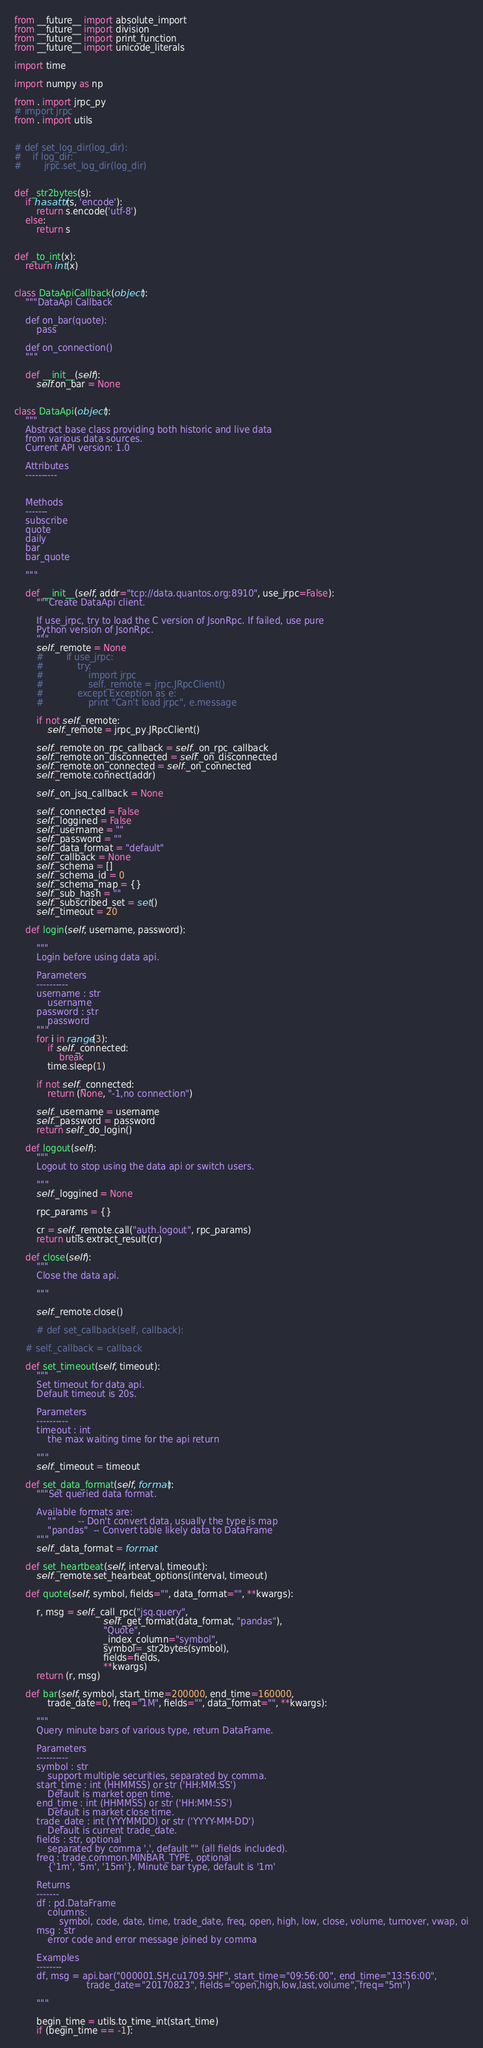<code> <loc_0><loc_0><loc_500><loc_500><_Python_>from __future__ import absolute_import
from __future__ import division
from __future__ import print_function
from __future__ import unicode_literals

import time

import numpy as np

from . import jrpc_py
# import jrpc
from . import utils


# def set_log_dir(log_dir):
#    if log_dir:
#        jrpc.set_log_dir(log_dir)


def _str2bytes(s):
    if hasattr(s, 'encode'):
        return s.encode('utf-8')
    else:
        return s


def _to_int(x):
    return int(x)


class DataApiCallback(object):
    """DataApi Callback

    def on_bar(quote):
        pass
        
    def on_connection()
    """
    
    def __init__(self):
        self.on_bar = None


class DataApi(object):
    """
    Abstract base class providing both historic and live data
    from various data sources.
    Current API version: 1.0   

    Attributes
    ----------
    

    Methods
    -------
    subscribe
    quote
    daily
    bar
    bar_quote    

    """
    
    def __init__(self, addr="tcp://data.quantos.org:8910", use_jrpc=False):
        """Create DataApi client.
        
        If use_jrpc, try to load the C version of JsonRpc. If failed, use pure
        Python version of JsonRpc.
        """
        self._remote = None
        #        if use_jrpc:
        #            try:
        #                import jrpc
        #                self._remote = jrpc.JRpcClient()
        #            except Exception as e:
        #                print "Can't load jrpc", e.message
        
        if not self._remote:
            self._remote = jrpc_py.JRpcClient()
        
        self._remote.on_rpc_callback = self._on_rpc_callback
        self._remote.on_disconnected = self._on_disconnected
        self._remote.on_connected = self._on_connected
        self._remote.connect(addr)
        
        self._on_jsq_callback = None
        
        self._connected = False
        self._loggined = False
        self._username = ""
        self._password = ""
        self._data_format = "default"
        self._callback = None
        self._schema = []
        self._schema_id = 0
        self._schema_map = {}
        self._sub_hash = ""
        self._subscribed_set = set()
        self._timeout = 20
    
    def login(self, username, password):
        
        """
        Login before using data api.

        Parameters
        ----------
        username : str
            username
        password : str
            password
        """
        for i in range(3):
            if self._connected:
                break
            time.sleep(1)
        
        if not self._connected:
            return (None, "-1,no connection")
        
        self._username = username
        self._password = password
        return self._do_login()
    
    def logout(self):
        """
        Logout to stop using the data api or switch users.

        """
        self._loggined = None
        
        rpc_params = {}
        
        cr = self._remote.call("auth.logout", rpc_params)
        return utils.extract_result(cr)
    
    def close(self):
        """
        Close the data api.

        """
        
        self._remote.close()
        
        # def set_callback(self, callback):
    
    # self._callback = callback
    
    def set_timeout(self, timeout):
        """
        Set timeout for data api. 
        Default timeout is 20s. 

        Parameters
        ----------
        timeout : int
            the max waiting time for the api return
        
        """
        self._timeout = timeout
    
    def set_data_format(self, format):
        """Set queried data format.
        
        Available formats are:
            ""        -- Don't convert data, usually the type is map
            "pandas"  -- Convert table likely data to DataFrame
        """
        self._data_format = format
    
    def set_heartbeat(self, interval, timeout):
        self._remote.set_hearbeat_options(interval, timeout)
    
    def quote(self, symbol, fields="", data_format="", **kwargs):
        
        r, msg = self._call_rpc("jsq.query",
                                self._get_format(data_format, "pandas"),
                                "Quote",
                                _index_column="symbol",
                                symbol=_str2bytes(symbol),
                                fields=fields,
                                **kwargs)
        return (r, msg)
    
    def bar(self, symbol, start_time=200000, end_time=160000,
            trade_date=0, freq="1M", fields="", data_format="", **kwargs):
        
        """
        Query minute bars of various type, return DataFrame.

        Parameters
        ----------
        symbol : str
            support multiple securities, separated by comma.
        start_time : int (HHMMSS) or str ('HH:MM:SS')
            Default is market open time.
        end_time : int (HHMMSS) or str ('HH:MM:SS')
            Default is market close time.
        trade_date : int (YYYMMDD) or str ('YYYY-MM-DD')
            Default is current trade_date.
        fields : str, optional
            separated by comma ',', default "" (all fields included).
        freq : trade.common.MINBAR_TYPE, optional
            {'1m', '5m', '15m'}, Minute bar type, default is '1m'

        Returns
        -------
        df : pd.DataFrame
            columns:
                symbol, code, date, time, trade_date, freq, open, high, low, close, volume, turnover, vwap, oi
        msg : str
            error code and error message joined by comma

        Examples
        --------
        df, msg = api.bar("000001.SH,cu1709.SHF", start_time="09:56:00", end_time="13:56:00",
                          trade_date="20170823", fields="open,high,low,last,volume", freq="5m")

        """
        
        begin_time = utils.to_time_int(start_time)
        if (begin_time == -1):</code> 